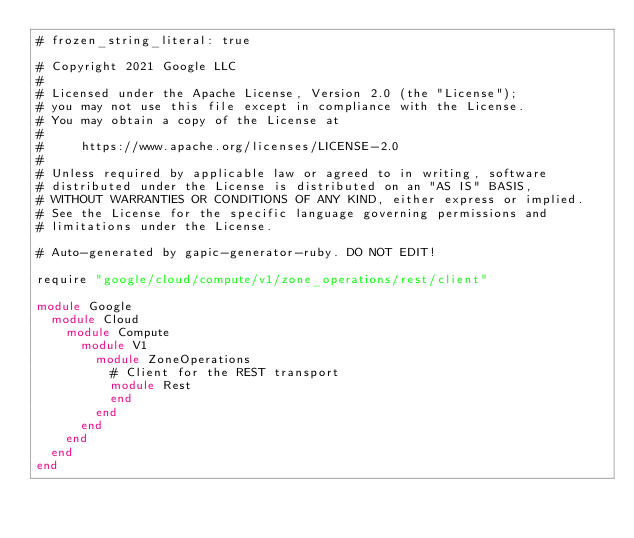Convert code to text. <code><loc_0><loc_0><loc_500><loc_500><_Ruby_># frozen_string_literal: true

# Copyright 2021 Google LLC
#
# Licensed under the Apache License, Version 2.0 (the "License");
# you may not use this file except in compliance with the License.
# You may obtain a copy of the License at
#
#     https://www.apache.org/licenses/LICENSE-2.0
#
# Unless required by applicable law or agreed to in writing, software
# distributed under the License is distributed on an "AS IS" BASIS,
# WITHOUT WARRANTIES OR CONDITIONS OF ANY KIND, either express or implied.
# See the License for the specific language governing permissions and
# limitations under the License.

# Auto-generated by gapic-generator-ruby. DO NOT EDIT!

require "google/cloud/compute/v1/zone_operations/rest/client"

module Google
  module Cloud
    module Compute
      module V1
        module ZoneOperations
          # Client for the REST transport
          module Rest
          end
        end
      end
    end
  end
end
</code> 